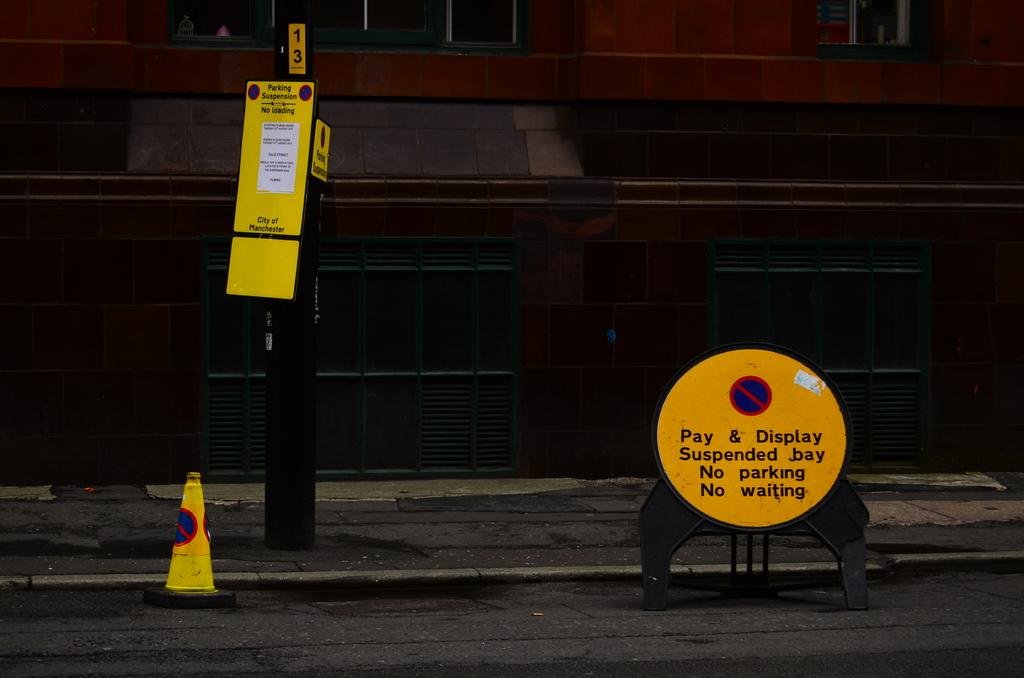<image>
Write a terse but informative summary of the picture. A buliding with a streetside that has warning signs that say there is a parking suspension - no parking, no waiting, no loading. 